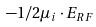Convert formula to latex. <formula><loc_0><loc_0><loc_500><loc_500>- 1 / 2 \mu _ { i } \cdot E _ { R F }</formula> 